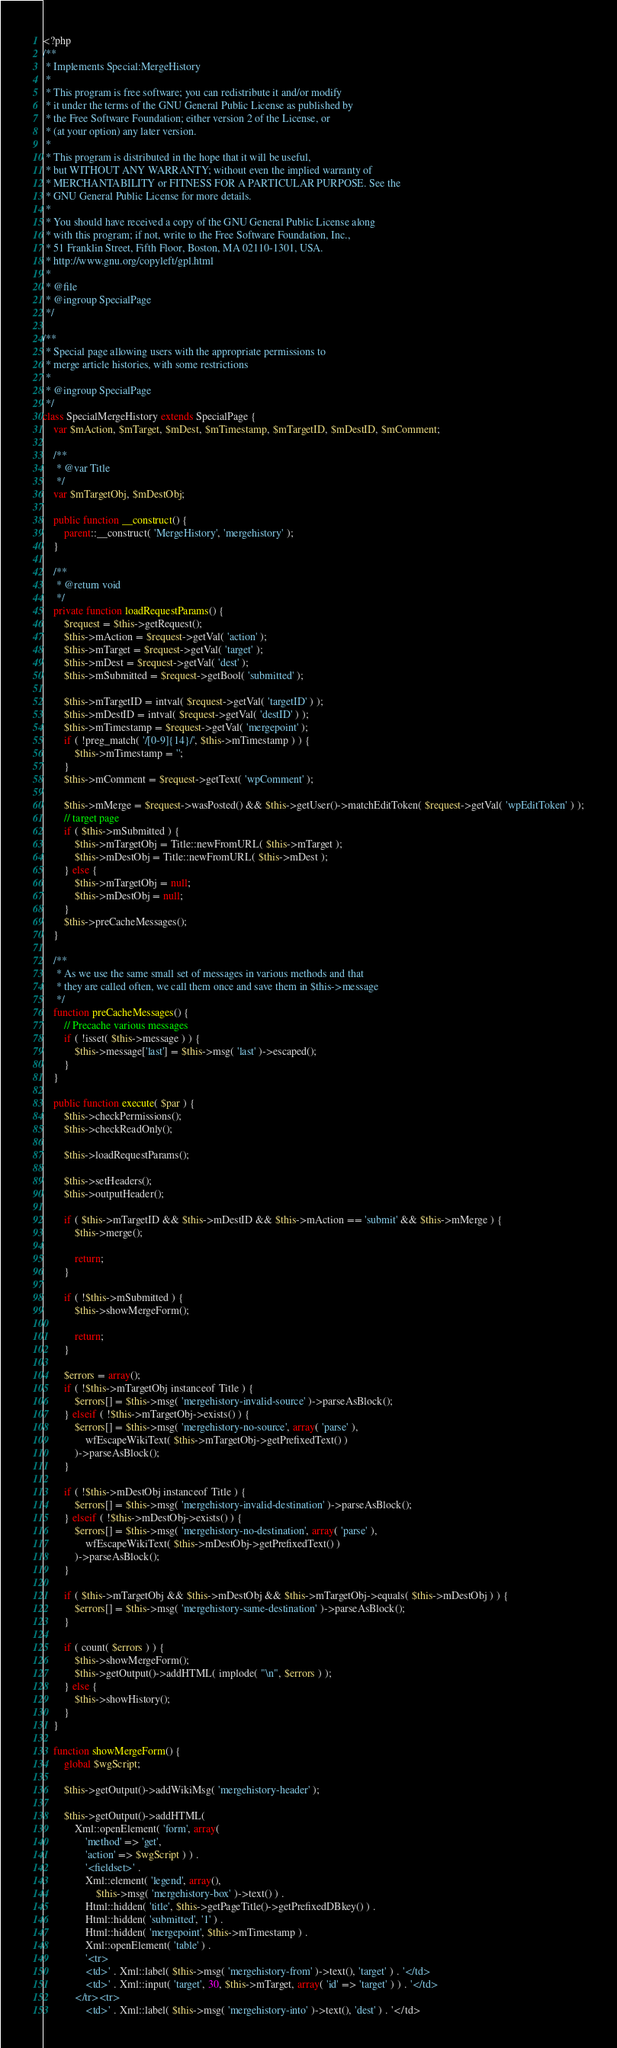Convert code to text. <code><loc_0><loc_0><loc_500><loc_500><_PHP_><?php
/**
 * Implements Special:MergeHistory
 *
 * This program is free software; you can redistribute it and/or modify
 * it under the terms of the GNU General Public License as published by
 * the Free Software Foundation; either version 2 of the License, or
 * (at your option) any later version.
 *
 * This program is distributed in the hope that it will be useful,
 * but WITHOUT ANY WARRANTY; without even the implied warranty of
 * MERCHANTABILITY or FITNESS FOR A PARTICULAR PURPOSE. See the
 * GNU General Public License for more details.
 *
 * You should have received a copy of the GNU General Public License along
 * with this program; if not, write to the Free Software Foundation, Inc.,
 * 51 Franklin Street, Fifth Floor, Boston, MA 02110-1301, USA.
 * http://www.gnu.org/copyleft/gpl.html
 *
 * @file
 * @ingroup SpecialPage
 */

/**
 * Special page allowing users with the appropriate permissions to
 * merge article histories, with some restrictions
 *
 * @ingroup SpecialPage
 */
class SpecialMergeHistory extends SpecialPage {
	var $mAction, $mTarget, $mDest, $mTimestamp, $mTargetID, $mDestID, $mComment;

	/**
	 * @var Title
	 */
	var $mTargetObj, $mDestObj;

	public function __construct() {
		parent::__construct( 'MergeHistory', 'mergehistory' );
	}

	/**
	 * @return void
	 */
	private function loadRequestParams() {
		$request = $this->getRequest();
		$this->mAction = $request->getVal( 'action' );
		$this->mTarget = $request->getVal( 'target' );
		$this->mDest = $request->getVal( 'dest' );
		$this->mSubmitted = $request->getBool( 'submitted' );

		$this->mTargetID = intval( $request->getVal( 'targetID' ) );
		$this->mDestID = intval( $request->getVal( 'destID' ) );
		$this->mTimestamp = $request->getVal( 'mergepoint' );
		if ( !preg_match( '/[0-9]{14}/', $this->mTimestamp ) ) {
			$this->mTimestamp = '';
		}
		$this->mComment = $request->getText( 'wpComment' );

		$this->mMerge = $request->wasPosted() && $this->getUser()->matchEditToken( $request->getVal( 'wpEditToken' ) );
		// target page
		if ( $this->mSubmitted ) {
			$this->mTargetObj = Title::newFromURL( $this->mTarget );
			$this->mDestObj = Title::newFromURL( $this->mDest );
		} else {
			$this->mTargetObj = null;
			$this->mDestObj = null;
		}
		$this->preCacheMessages();
	}

	/**
	 * As we use the same small set of messages in various methods and that
	 * they are called often, we call them once and save them in $this->message
	 */
	function preCacheMessages() {
		// Precache various messages
		if ( !isset( $this->message ) ) {
			$this->message['last'] = $this->msg( 'last' )->escaped();
		}
	}

	public function execute( $par ) {
		$this->checkPermissions();
		$this->checkReadOnly();

		$this->loadRequestParams();

		$this->setHeaders();
		$this->outputHeader();

		if ( $this->mTargetID && $this->mDestID && $this->mAction == 'submit' && $this->mMerge ) {
			$this->merge();

			return;
		}

		if ( !$this->mSubmitted ) {
			$this->showMergeForm();

			return;
		}

		$errors = array();
		if ( !$this->mTargetObj instanceof Title ) {
			$errors[] = $this->msg( 'mergehistory-invalid-source' )->parseAsBlock();
		} elseif ( !$this->mTargetObj->exists() ) {
			$errors[] = $this->msg( 'mergehistory-no-source', array( 'parse' ),
				wfEscapeWikiText( $this->mTargetObj->getPrefixedText() )
			)->parseAsBlock();
		}

		if ( !$this->mDestObj instanceof Title ) {
			$errors[] = $this->msg( 'mergehistory-invalid-destination' )->parseAsBlock();
		} elseif ( !$this->mDestObj->exists() ) {
			$errors[] = $this->msg( 'mergehistory-no-destination', array( 'parse' ),
				wfEscapeWikiText( $this->mDestObj->getPrefixedText() )
			)->parseAsBlock();
		}

		if ( $this->mTargetObj && $this->mDestObj && $this->mTargetObj->equals( $this->mDestObj ) ) {
			$errors[] = $this->msg( 'mergehistory-same-destination' )->parseAsBlock();
		}

		if ( count( $errors ) ) {
			$this->showMergeForm();
			$this->getOutput()->addHTML( implode( "\n", $errors ) );
		} else {
			$this->showHistory();
		}
	}

	function showMergeForm() {
		global $wgScript;

		$this->getOutput()->addWikiMsg( 'mergehistory-header' );

		$this->getOutput()->addHTML(
			Xml::openElement( 'form', array(
				'method' => 'get',
				'action' => $wgScript ) ) .
				'<fieldset>' .
				Xml::element( 'legend', array(),
					$this->msg( 'mergehistory-box' )->text() ) .
				Html::hidden( 'title', $this->getPageTitle()->getPrefixedDBkey() ) .
				Html::hidden( 'submitted', '1' ) .
				Html::hidden( 'mergepoint', $this->mTimestamp ) .
				Xml::openElement( 'table' ) .
				'<tr>
				<td>' . Xml::label( $this->msg( 'mergehistory-from' )->text(), 'target' ) . '</td>
				<td>' . Xml::input( 'target', 30, $this->mTarget, array( 'id' => 'target' ) ) . '</td>
			</tr><tr>
				<td>' . Xml::label( $this->msg( 'mergehistory-into' )->text(), 'dest' ) . '</td></code> 